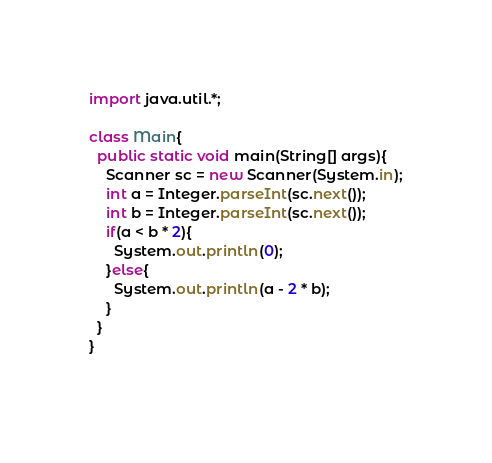Convert code to text. <code><loc_0><loc_0><loc_500><loc_500><_Java_>import java.util.*;

class Main{
  public static void main(String[] args){
    Scanner sc = new Scanner(System.in);
    int a = Integer.parseInt(sc.next());
    int b = Integer.parseInt(sc.next());
    if(a < b * 2){
      System.out.println(0);
    }else{
      System.out.println(a - 2 * b);
    }
  }
}
    </code> 